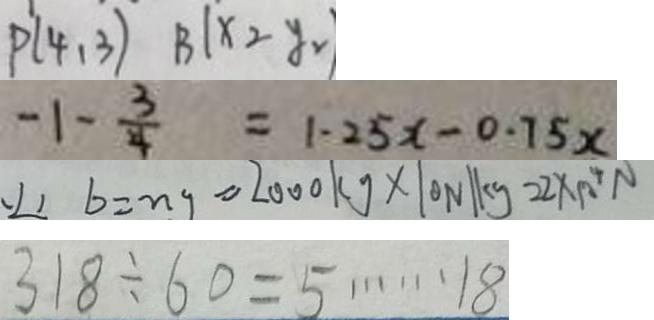Convert formula to latex. <formula><loc_0><loc_0><loc_500><loc_500>p 1 ( 4 , 3 ) B 1 \times 2 y = 
 - 1 - \frac { 3 } { 4 } = 1 . 2 5 x - 0 . 7 5 x 
 ( 2 ) b = n g = 2 0 0 0 k g \times 1 0 N / k g = 2 \times 1 0 ^ { 4 } N 
 3 1 8 \div 6 0 = 5 \cdots 1 8</formula> 